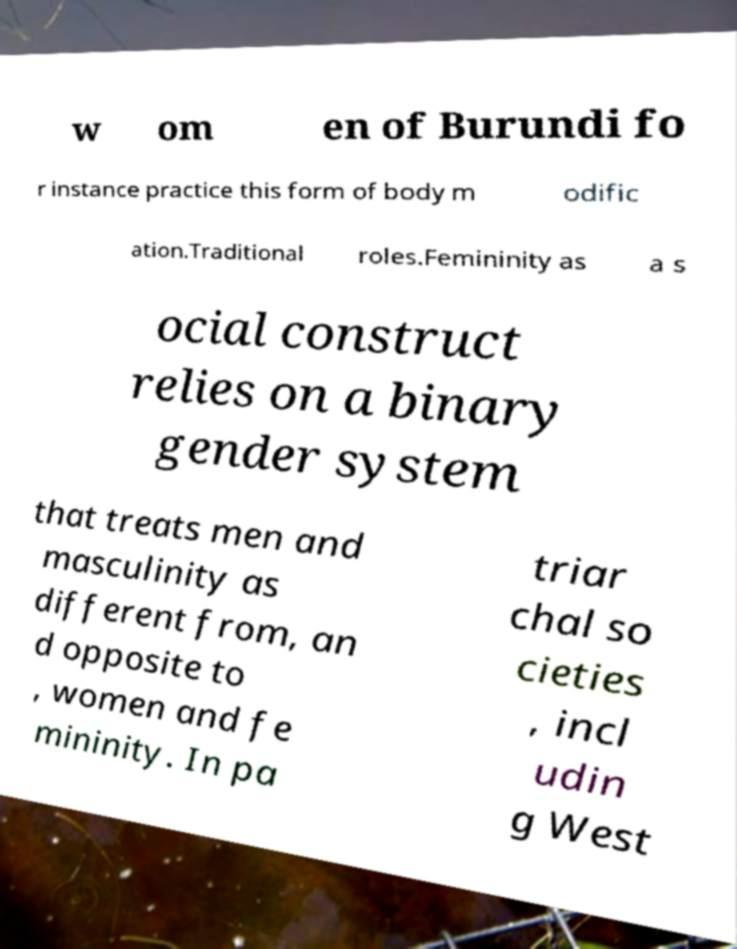I need the written content from this picture converted into text. Can you do that? w om en of Burundi fo r instance practice this form of body m odific ation.Traditional roles.Femininity as a s ocial construct relies on a binary gender system that treats men and masculinity as different from, an d opposite to , women and fe mininity. In pa triar chal so cieties , incl udin g West 